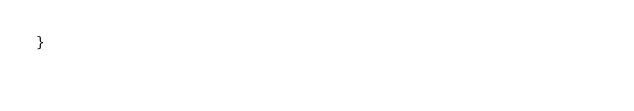Convert code to text. <code><loc_0><loc_0><loc_500><loc_500><_TypeScript_>}
</code> 